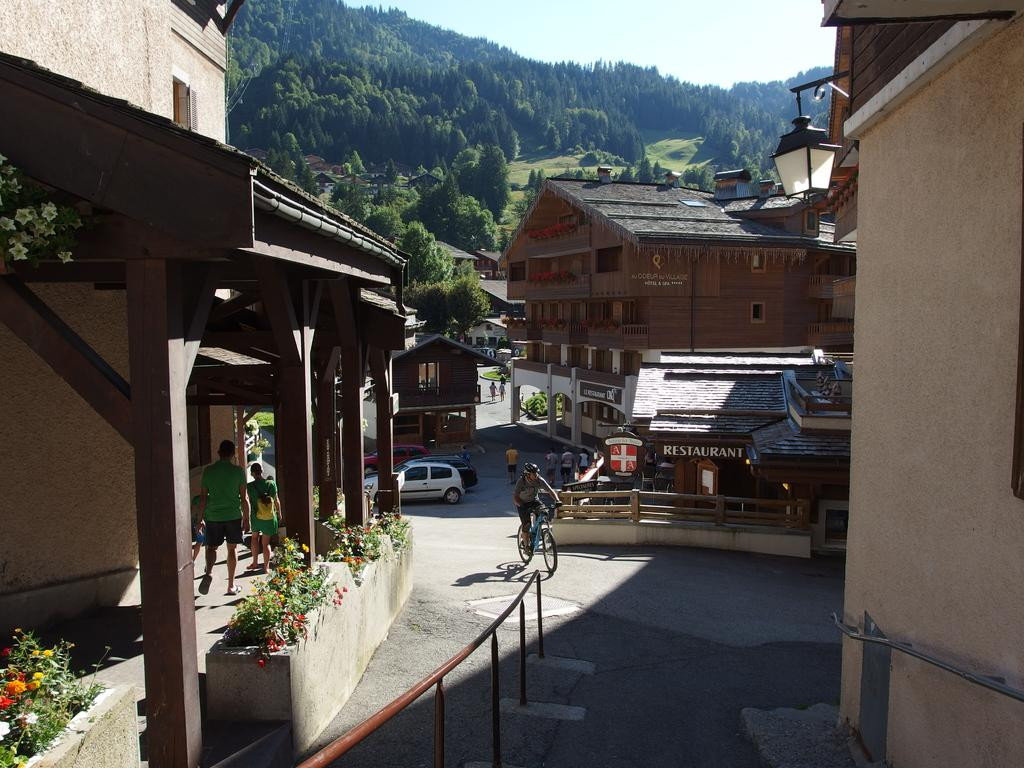<image>
Give a short and clear explanation of the subsequent image. Small town with a Restaurant  near the back. 